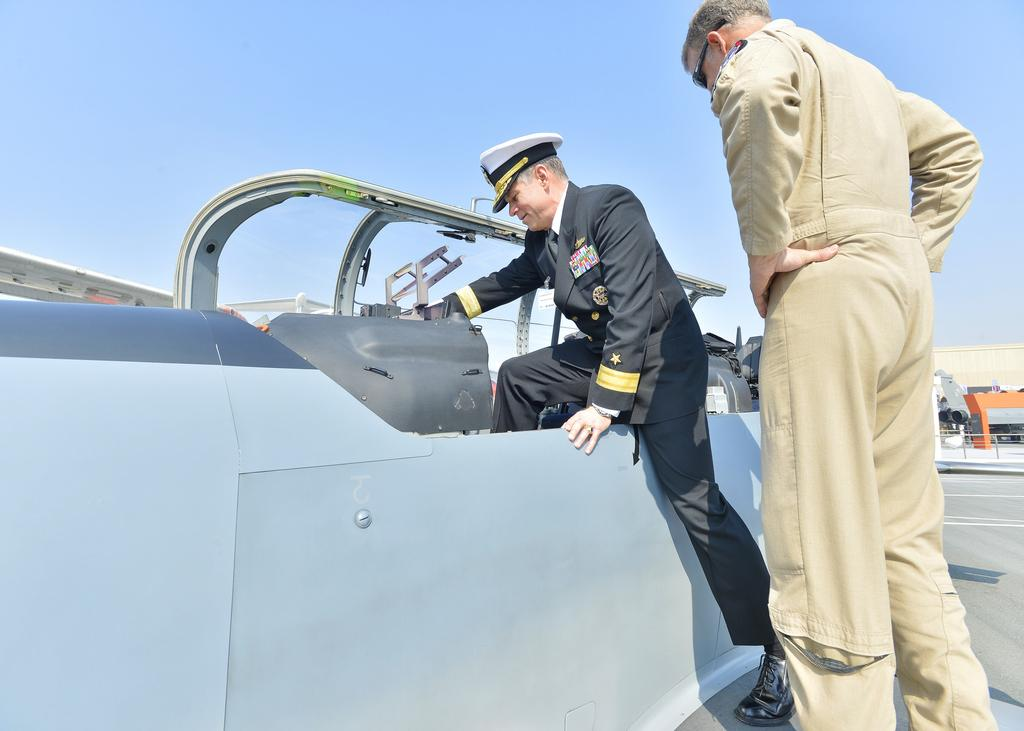What is the main subject of the image? There is a man standing in the image. What is the other man in the image doing? Another man is getting into a vehicle. What type of architectural feature is present in the image? There is a glass door in the image. What can be seen in the background of the image? There is a building in the background of the image. What is visible in the sky in the image? The sky is visible in the image. Can you see any clouds or a harbor in the image? There are no clouds or harbor visible in the image. Is there a glove being used by either man in the image? There is no glove present in the image. 